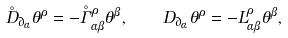<formula> <loc_0><loc_0><loc_500><loc_500>\mathring { D } _ { \partial _ { \alpha } } \theta ^ { \rho } = - \mathring { \Gamma } _ { \alpha \beta } ^ { \rho } \theta ^ { \beta } , \quad D _ { \partial _ { \alpha } } \theta ^ { \rho } = - L _ { \alpha \beta } ^ { \rho } \theta ^ { \beta } ,</formula> 